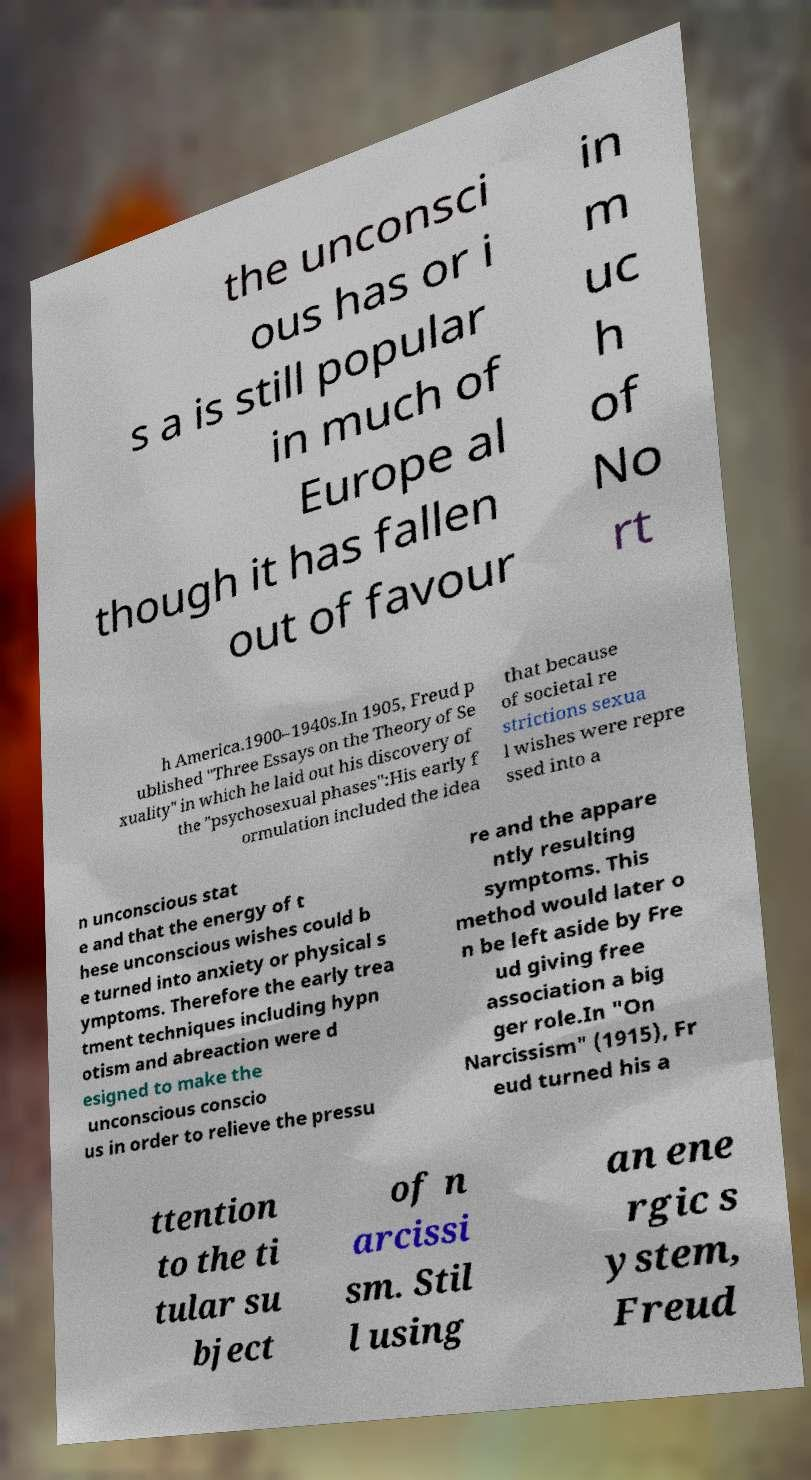I need the written content from this picture converted into text. Can you do that? the unconsci ous has or i s a is still popular in much of Europe al though it has fallen out of favour in m uc h of No rt h America.1900–1940s.In 1905, Freud p ublished "Three Essays on the Theory of Se xuality" in which he laid out his discovery of the "psychosexual phases":His early f ormulation included the idea that because of societal re strictions sexua l wishes were repre ssed into a n unconscious stat e and that the energy of t hese unconscious wishes could b e turned into anxiety or physical s ymptoms. Therefore the early trea tment techniques including hypn otism and abreaction were d esigned to make the unconscious conscio us in order to relieve the pressu re and the appare ntly resulting symptoms. This method would later o n be left aside by Fre ud giving free association a big ger role.In "On Narcissism" (1915), Fr eud turned his a ttention to the ti tular su bject of n arcissi sm. Stil l using an ene rgic s ystem, Freud 